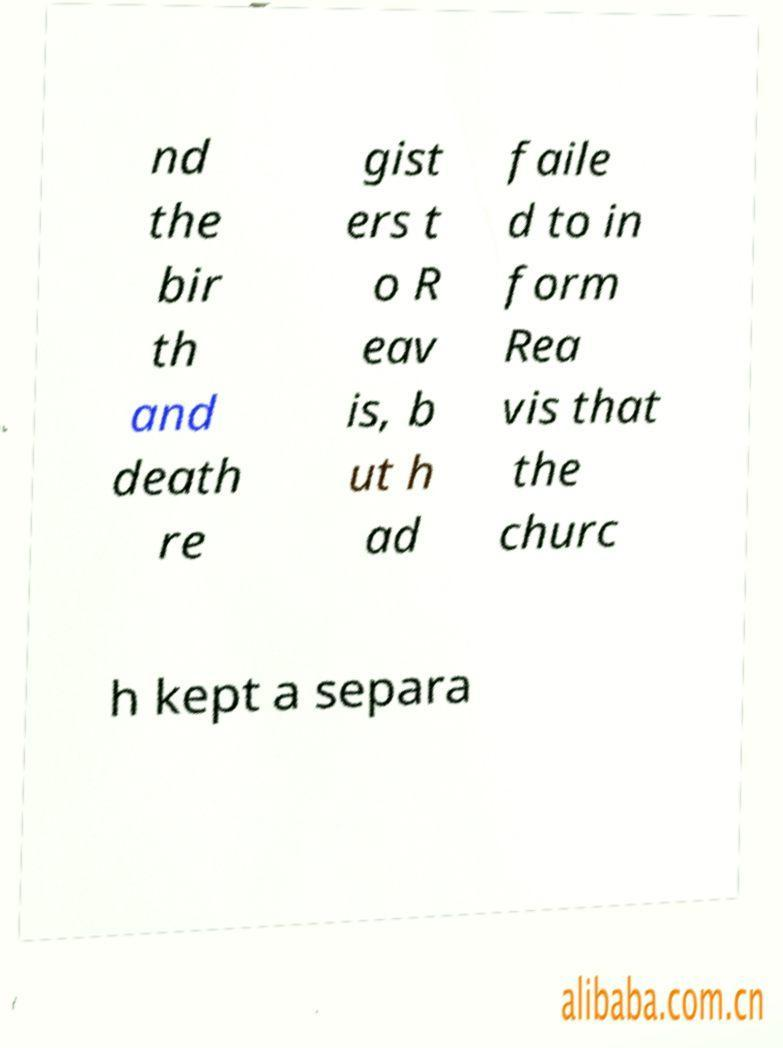Could you extract and type out the text from this image? nd the bir th and death re gist ers t o R eav is, b ut h ad faile d to in form Rea vis that the churc h kept a separa 